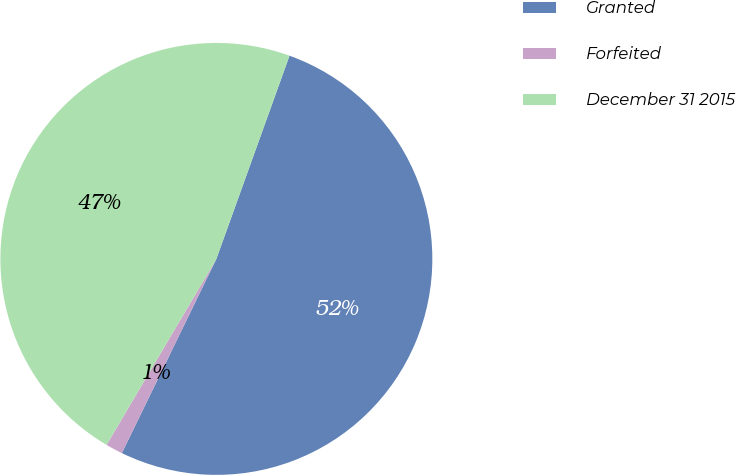Convert chart to OTSL. <chart><loc_0><loc_0><loc_500><loc_500><pie_chart><fcel>Granted<fcel>Forfeited<fcel>December 31 2015<nl><fcel>51.71%<fcel>1.28%<fcel>47.01%<nl></chart> 